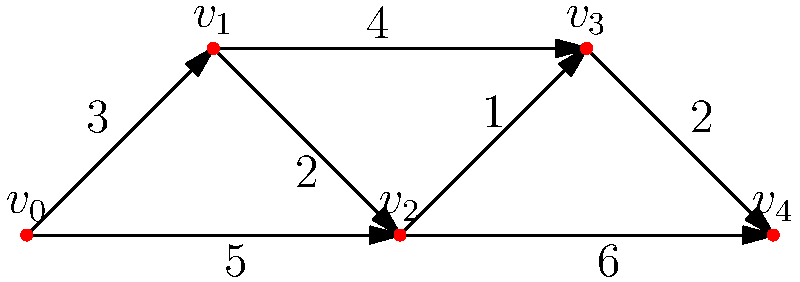Given the directed graph representing secure intelligence routes between five locations ($v_0$ to $v_4$), with edge weights indicating the risk level of each route, what is the minimum total risk level for a secure path from $v_0$ to $v_4$? To find the minimum total risk level from $v_0$ to $v_4$, we'll use Dijkstra's algorithm:

1. Initialize:
   - Distance to $v_0$ = 0
   - Distance to all other vertices = $\infty$

2. Start from $v_0$:
   - Update neighbors:
     $d(v_1) = \min(\infty, 0 + 3) = 3$
     $d(v_2) = \min(\infty, 0 + 5) = 5$

3. Select vertex with minimum distance (v_1):
   - Update neighbors:
     $d(v_2) = \min(5, 3 + 2) = 5$
     $d(v_3) = \min(\infty, 3 + 4) = 7$

4. Select next minimum (v_2):
   - Update neighbors:
     $d(v_3) = \min(7, 5 + 1) = 6$
     $d(v_4) = \min(\infty, 5 + 6) = 11$

5. Select next minimum (v_3):
   - Update neighbor:
     $d(v_4) = \min(11, 6 + 2) = 8$

6. Select v_4 (destination reached)

The minimum total risk level from $v_0$ to $v_4$ is 8.

The path is $v_0 \rightarrow v_1 \rightarrow v_2 \rightarrow v_3 \rightarrow v_4$ with risk levels $3 + 2 + 1 + 2 = 8$.
Answer: 8 